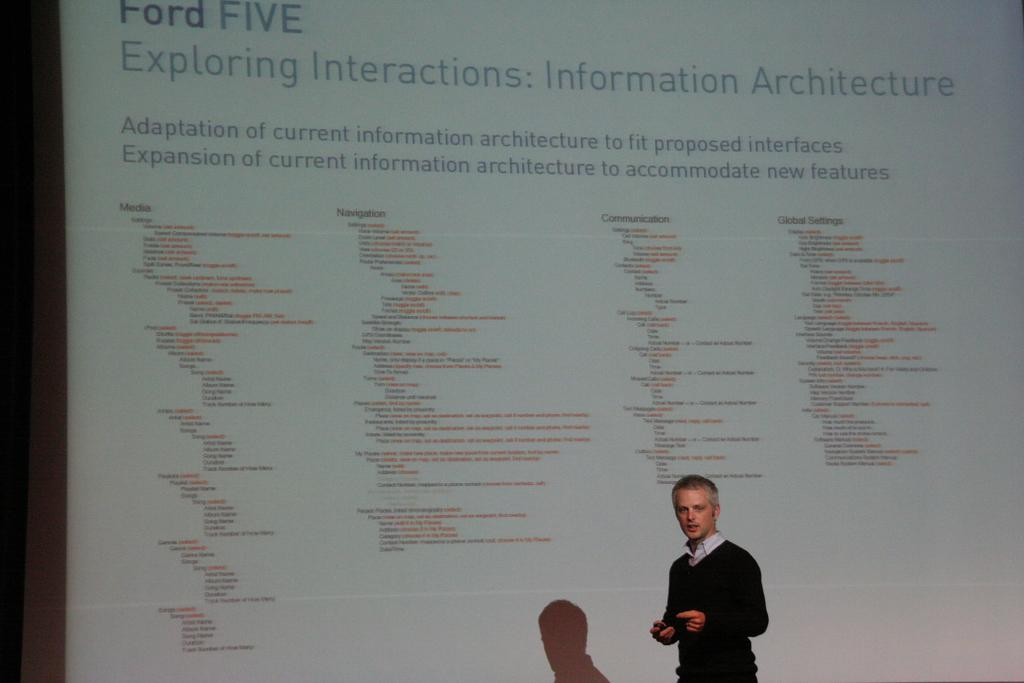What is the man in the image doing? The man is giving a seminar. What can be seen behind the man in the image? There is a screen with information behind the man. What is the man wearing in the image? The man in the image is wearing a black shirt. What type of whistle can be heard during the seminar in the image? There is no whistle present or audible in the image, as it is a still photograph. 